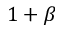<formula> <loc_0><loc_0><loc_500><loc_500>1 + \beta</formula> 